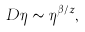Convert formula to latex. <formula><loc_0><loc_0><loc_500><loc_500>D \eta \sim \eta ^ { \beta / z } ,</formula> 